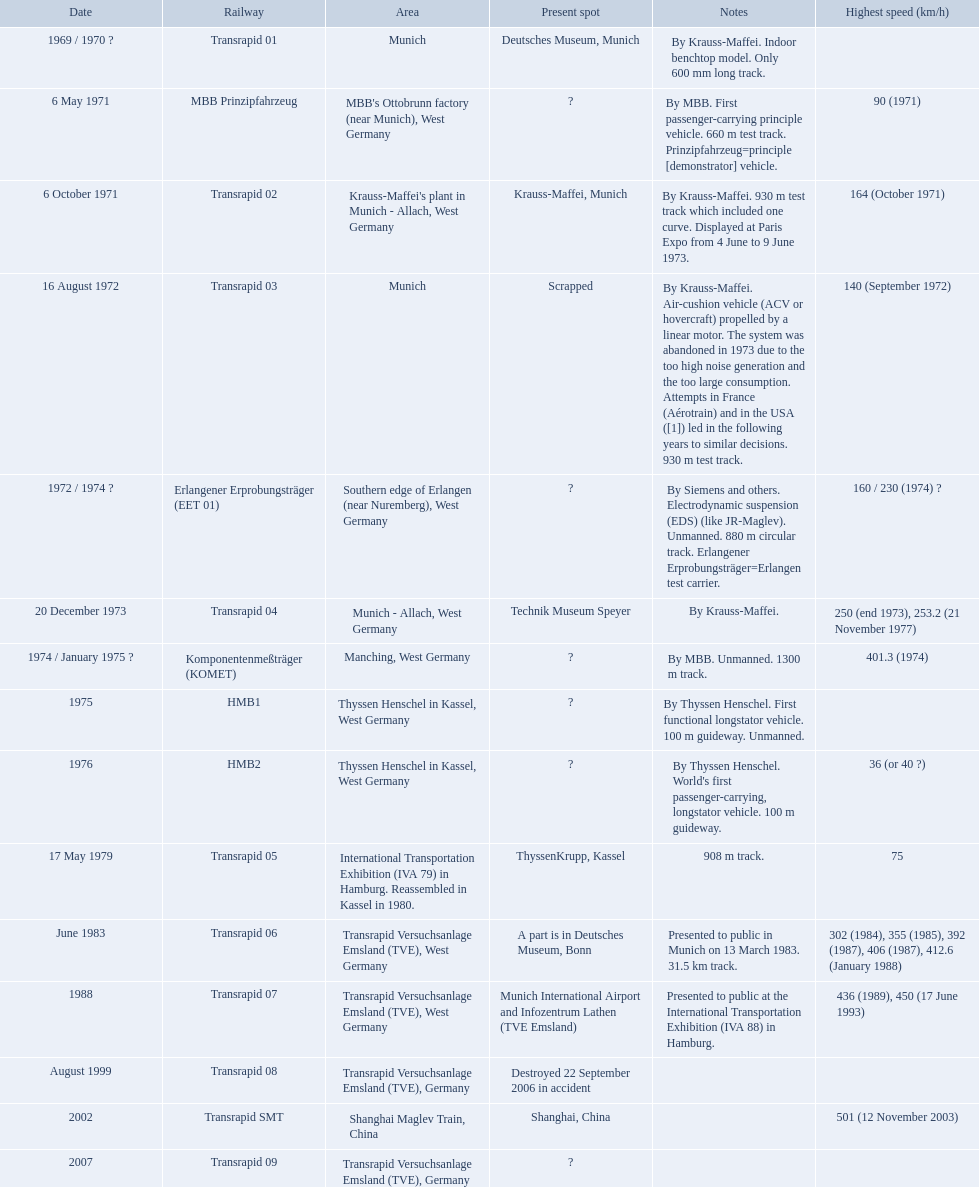What are the names of each transrapid train? Transrapid 01, MBB Prinzipfahrzeug, Transrapid 02, Transrapid 03, Erlangener Erprobungsträger (EET 01), Transrapid 04, Komponentenmeßträger (KOMET), HMB1, HMB2, Transrapid 05, Transrapid 06, Transrapid 07, Transrapid 08, Transrapid SMT, Transrapid 09. What are their listed top speeds? 90 (1971), 164 (October 1971), 140 (September 1972), 160 / 230 (1974) ?, 250 (end 1973), 253.2 (21 November 1977), 401.3 (1974), 36 (or 40 ?), 75, 302 (1984), 355 (1985), 392 (1987), 406 (1987), 412.6 (January 1988), 436 (1989), 450 (17 June 1993), 501 (12 November 2003). And which train operates at the fastest speed? Transrapid SMT. Would you be able to parse every entry in this table? {'header': ['Date', 'Railway', 'Area', 'Present spot', 'Notes', 'Highest speed (km/h)'], 'rows': [['1969 / 1970\xa0?', 'Transrapid 01', 'Munich', 'Deutsches Museum, Munich', 'By Krauss-Maffei. Indoor benchtop model. Only 600\xa0mm long track.', ''], ['6 May 1971', 'MBB Prinzipfahrzeug', "MBB's Ottobrunn factory (near Munich), West Germany", '?', 'By MBB. First passenger-carrying principle vehicle. 660 m test track. Prinzipfahrzeug=principle [demonstrator] vehicle.', '90 (1971)'], ['6 October 1971', 'Transrapid 02', "Krauss-Maffei's plant in Munich - Allach, West Germany", 'Krauss-Maffei, Munich', 'By Krauss-Maffei. 930 m test track which included one curve. Displayed at Paris Expo from 4 June to 9 June 1973.', '164 (October 1971)'], ['16 August 1972', 'Transrapid 03', 'Munich', 'Scrapped', 'By Krauss-Maffei. Air-cushion vehicle (ACV or hovercraft) propelled by a linear motor. The system was abandoned in 1973 due to the too high noise generation and the too large consumption. Attempts in France (Aérotrain) and in the USA ([1]) led in the following years to similar decisions. 930 m test track.', '140 (September 1972)'], ['1972 / 1974\xa0?', 'Erlangener Erprobungsträger (EET 01)', 'Southern edge of Erlangen (near Nuremberg), West Germany', '?', 'By Siemens and others. Electrodynamic suspension (EDS) (like JR-Maglev). Unmanned. 880 m circular track. Erlangener Erprobungsträger=Erlangen test carrier.', '160 / 230 (1974)\xa0?'], ['20 December 1973', 'Transrapid 04', 'Munich - Allach, West Germany', 'Technik Museum Speyer', 'By Krauss-Maffei.', '250 (end 1973), 253.2 (21 November 1977)'], ['1974 / January 1975\xa0?', 'Komponentenmeßträger (KOMET)', 'Manching, West Germany', '?', 'By MBB. Unmanned. 1300 m track.', '401.3 (1974)'], ['1975', 'HMB1', 'Thyssen Henschel in Kassel, West Germany', '?', 'By Thyssen Henschel. First functional longstator vehicle. 100 m guideway. Unmanned.', ''], ['1976', 'HMB2', 'Thyssen Henschel in Kassel, West Germany', '?', "By Thyssen Henschel. World's first passenger-carrying, longstator vehicle. 100 m guideway.", '36 (or 40\xa0?)'], ['17 May 1979', 'Transrapid 05', 'International Transportation Exhibition (IVA 79) in Hamburg. Reassembled in Kassel in 1980.', 'ThyssenKrupp, Kassel', '908 m track.', '75'], ['June 1983', 'Transrapid 06', 'Transrapid Versuchsanlage Emsland (TVE), West Germany', 'A part is in Deutsches Museum, Bonn', 'Presented to public in Munich on 13 March 1983. 31.5\xa0km track.', '302 (1984), 355 (1985), 392 (1987), 406 (1987), 412.6 (January 1988)'], ['1988', 'Transrapid 07', 'Transrapid Versuchsanlage Emsland (TVE), West Germany', 'Munich International Airport and Infozentrum Lathen (TVE Emsland)', 'Presented to public at the International Transportation Exhibition (IVA 88) in Hamburg.', '436 (1989), 450 (17 June 1993)'], ['August 1999', 'Transrapid 08', 'Transrapid Versuchsanlage Emsland (TVE), Germany', 'Destroyed 22 September 2006 in accident', '', ''], ['2002', 'Transrapid SMT', 'Shanghai Maglev Train, China', 'Shanghai, China', '', '501 (12 November 2003)'], ['2007', 'Transrapid 09', 'Transrapid Versuchsanlage Emsland (TVE), Germany', '?', '', '']]} Which trains exceeded a top speed of 400+? Komponentenmeßträger (KOMET), Transrapid 07, Transrapid SMT. How about 500+? Transrapid SMT. 